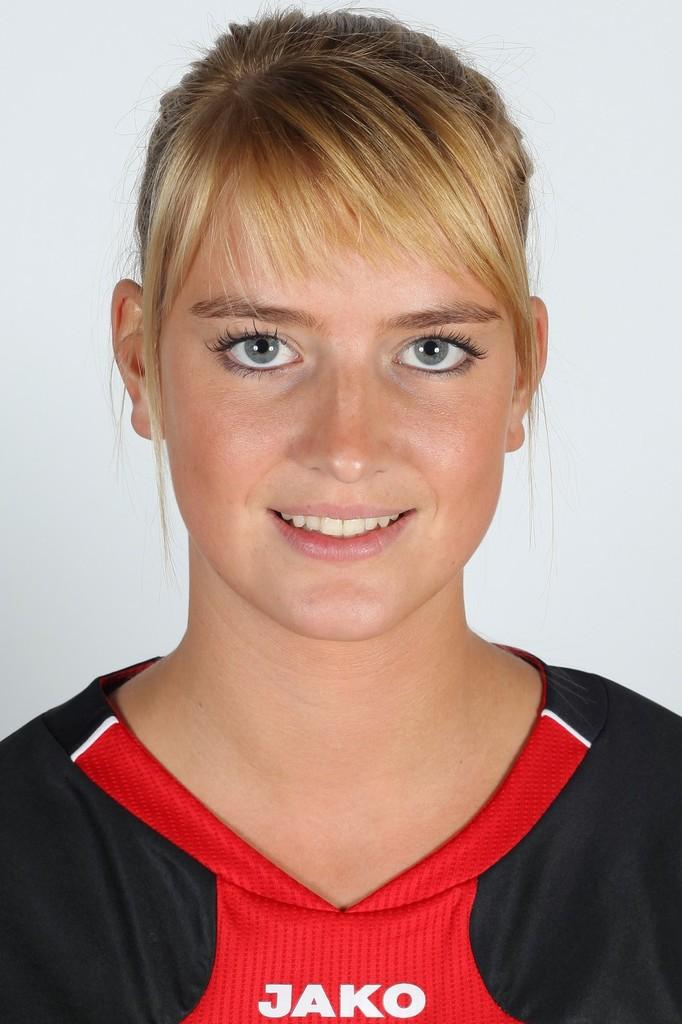What is the brand on this person's shirt?
Your response must be concise. Jako. 